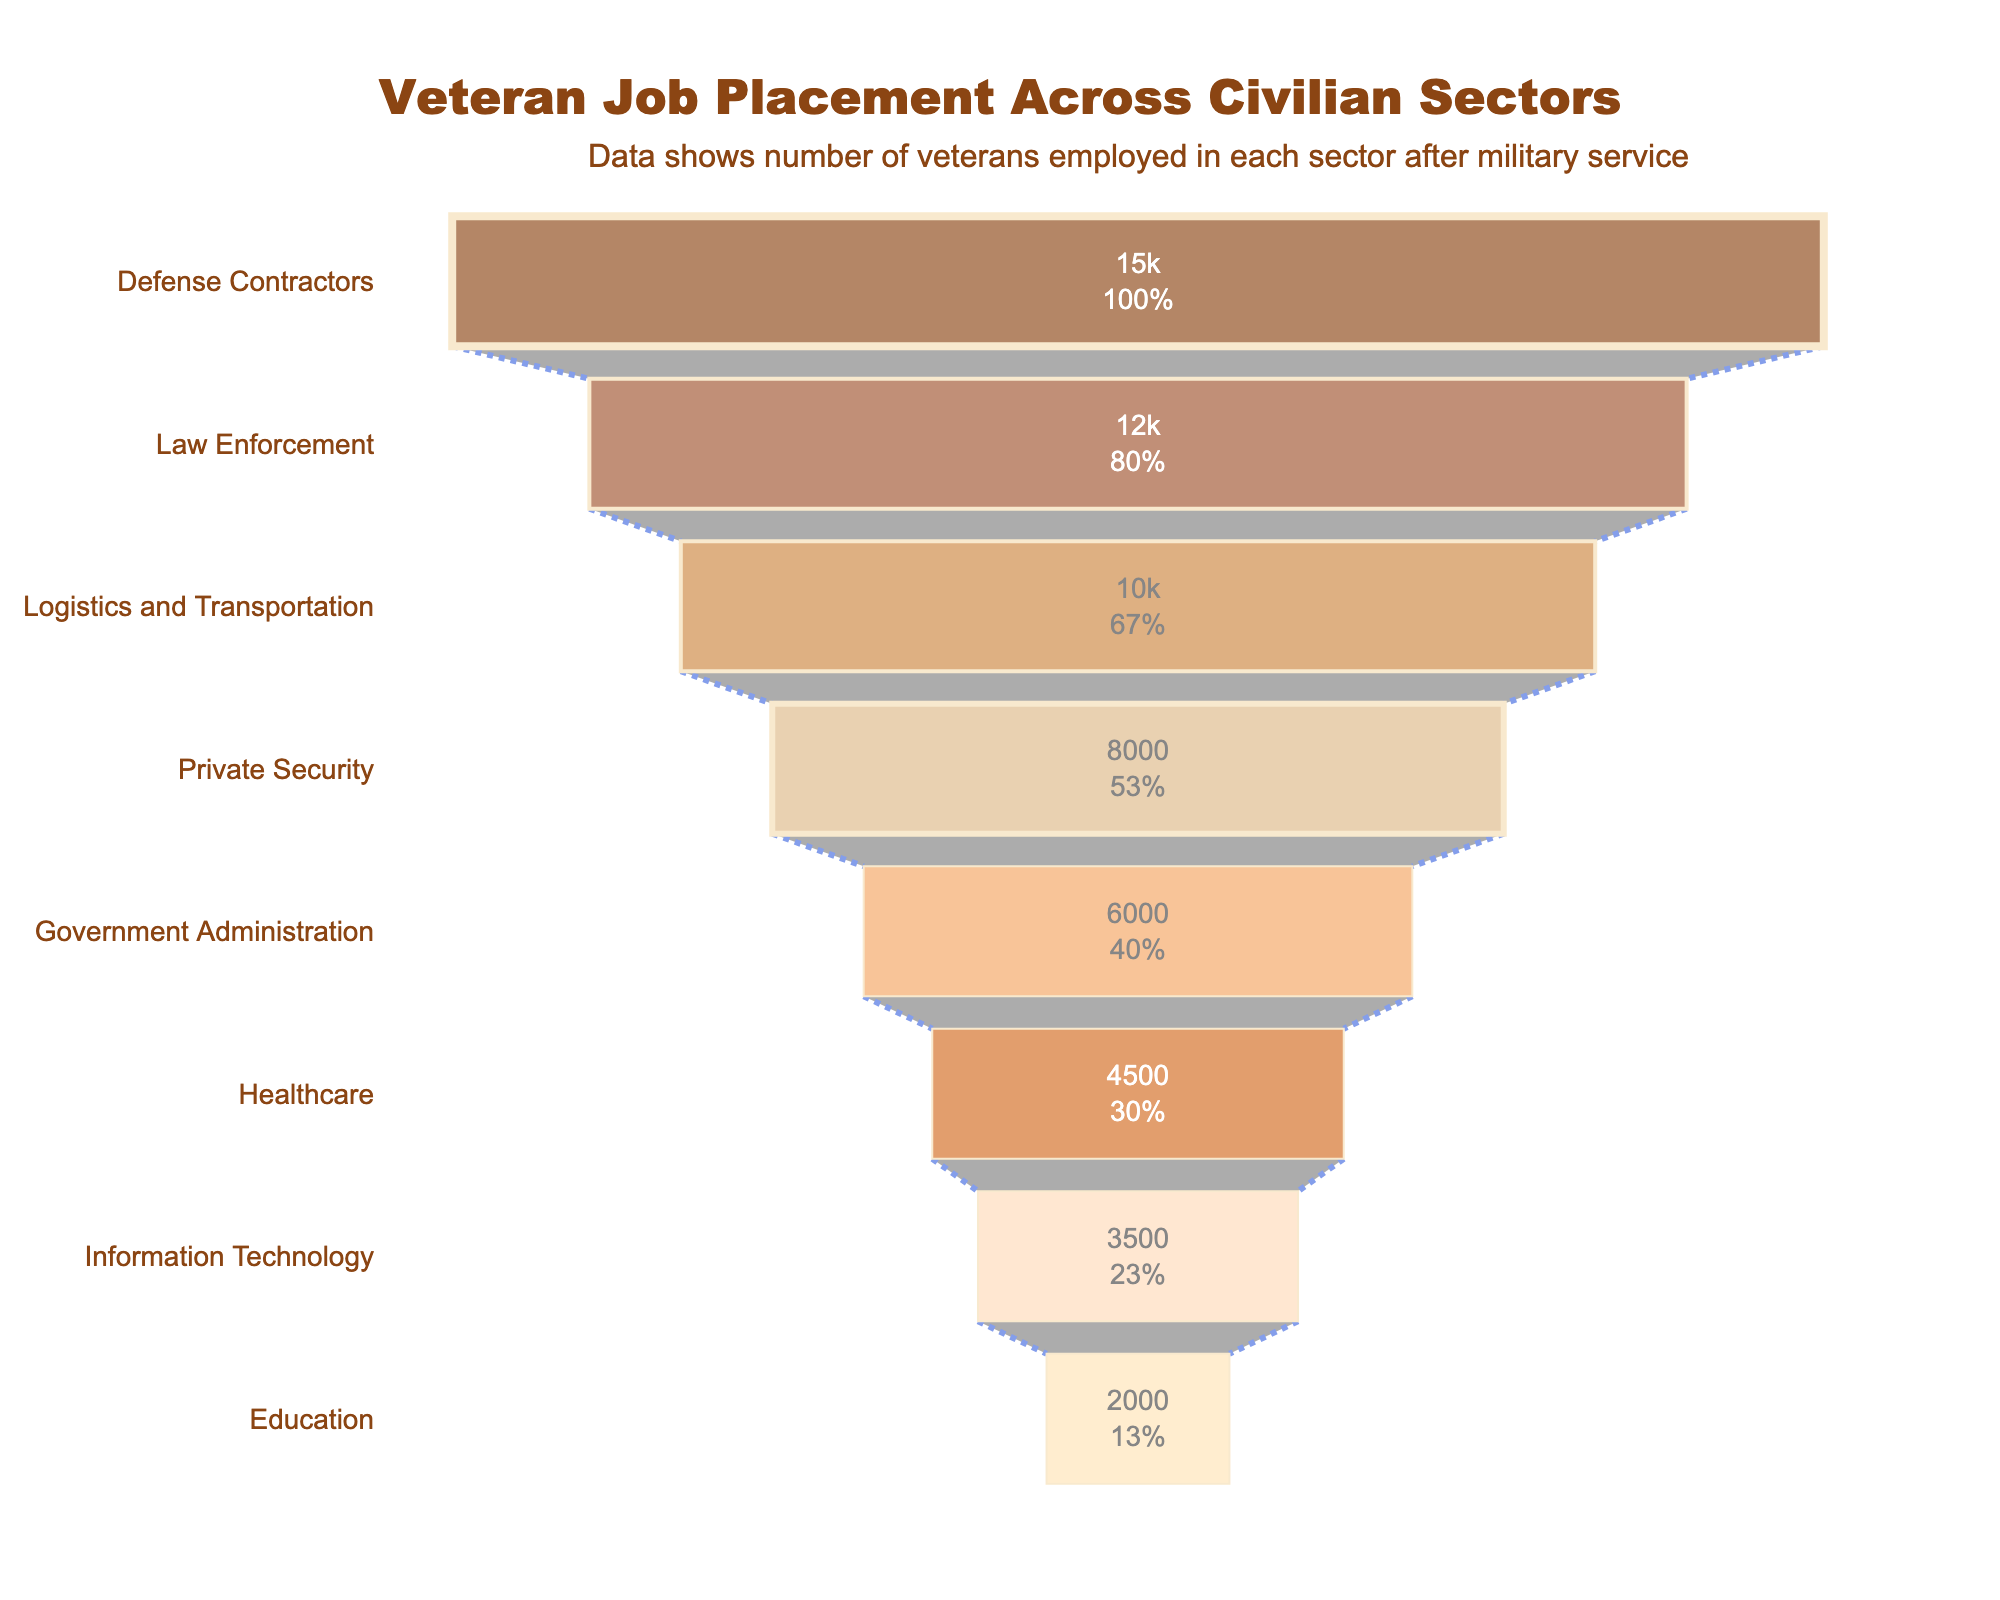What's the title of the funnel chart? The title is displayed at the top of the chart. It reads "Veteran Job Placement Across Civilian Sectors", highlighting the subject of the visualization.
Answer: Veteran Job Placement Across Civilian Sectors Which sector employs the highest number of veterans? By examining the funnel chart, the widest segment represents the sector with the highest number of veterans employed. The "Defense Contractors" segment is the widest, showing it employs the most veterans.
Answer: Defense Contractors What percentage of the initial number of veterans is employed in Healthcare? Look at the "Healthcare" segment in the funnel chart and read the percentage value provided inside the segment. The percentage is calculated based on the total initial number of veterans.
Answer: 9% How many veterans are employed in the Information Technology sector? The "Information Technology" segment in the funnel chart indicates the number of veterans. It shows the value directly within the segment.
Answer: 3500 Which sectors employ fewer than 10,000 veterans? By comparing the widths of the segments and checking their values, we identify that sectors like "Private Security", "Government Administration", "Healthcare", "Information Technology", and "Education" each employ fewer than 10,000 veterans.
Answer: Private Security, Government Administration, Healthcare, Information Technology, Education How many sectors employ more than 5,000 but less than 15,000 veterans? Count the segments representing sectors where the number of veterans employed falls within the range of 5,000 to 15,000. These sectors are "Law Enforcement", "Logistics and Transportation", and "Private Security".
Answer: 3 How many more veterans are employed in Defense Contractors compared to Education? Subtract the number of veterans employed in the Education sector from the number employed in Defense Contractors. Specifically, 15,000 - 2,000 = 13,000.
Answer: 13,000 What is the combined number of veterans employed in Law Enforcement and Healthcare? Sum the number of veterans employed in Law Enforcement with those employed in Healthcare. Specifically, 12,000 + 4,500 = 16,500.
Answer: 16,500 What is the least common sector for veteran employment? The narrowest segment represents the sector with the least number of veterans employed. "Education" is the narrowest segment.
Answer: Education 